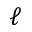Convert formula to latex. <formula><loc_0><loc_0><loc_500><loc_500>\ell</formula> 